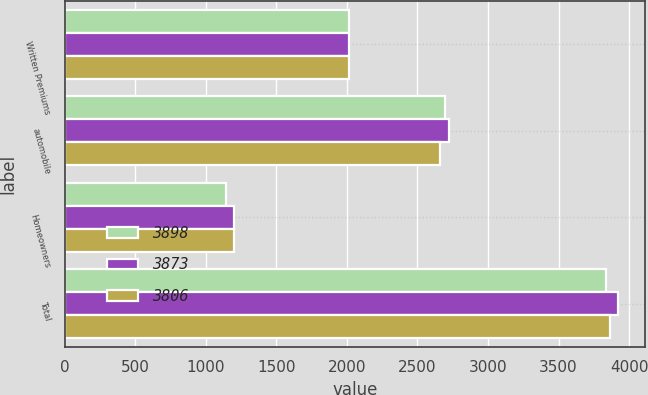Convert chart to OTSL. <chart><loc_0><loc_0><loc_500><loc_500><stacked_bar_chart><ecel><fcel>Written Premiums<fcel>automobile<fcel>Homeowners<fcel>Total<nl><fcel>3898<fcel>2016<fcel>2694<fcel>1143<fcel>3837<nl><fcel>3873<fcel>2015<fcel>2721<fcel>1197<fcel>3918<nl><fcel>3806<fcel>2014<fcel>2659<fcel>1202<fcel>3861<nl></chart> 